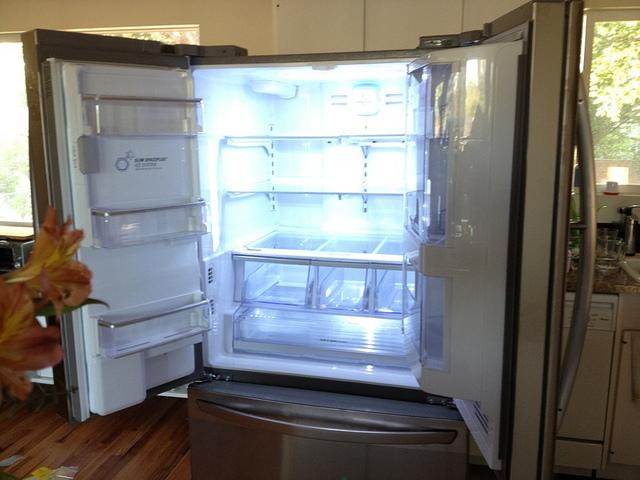Why is the refrigerator empty?
Quick response, please. New. Are the doors closed?
Give a very brief answer. No. Is the light on in the fridge?
Give a very brief answer. Yes. Is the appliance clean?
Keep it brief. Yes. Is there any food in the refrigerator?
Quick response, please. No. 